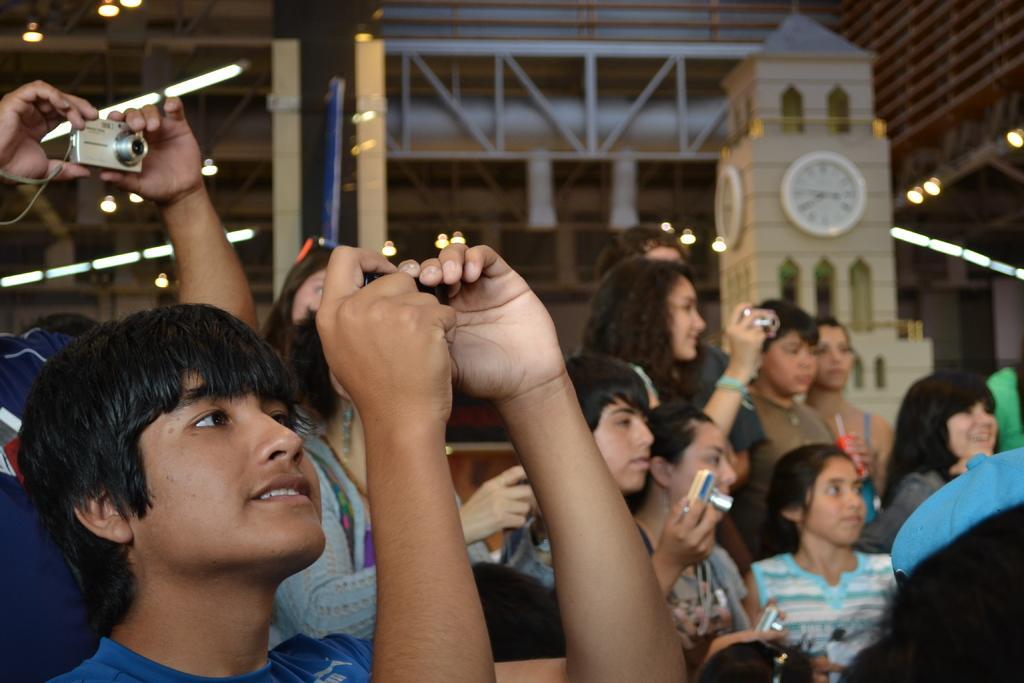Can you describe this image briefly? In this image there are a few kids holding cameras in their hands and clicking pictures, behind them there is a clock tower and a metal structure. 